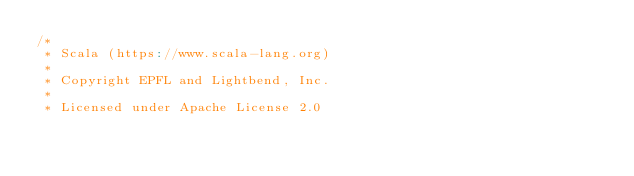<code> <loc_0><loc_0><loc_500><loc_500><_Scala_>/*
 * Scala (https://www.scala-lang.org)
 *
 * Copyright EPFL and Lightbend, Inc.
 *
 * Licensed under Apache License 2.0</code> 